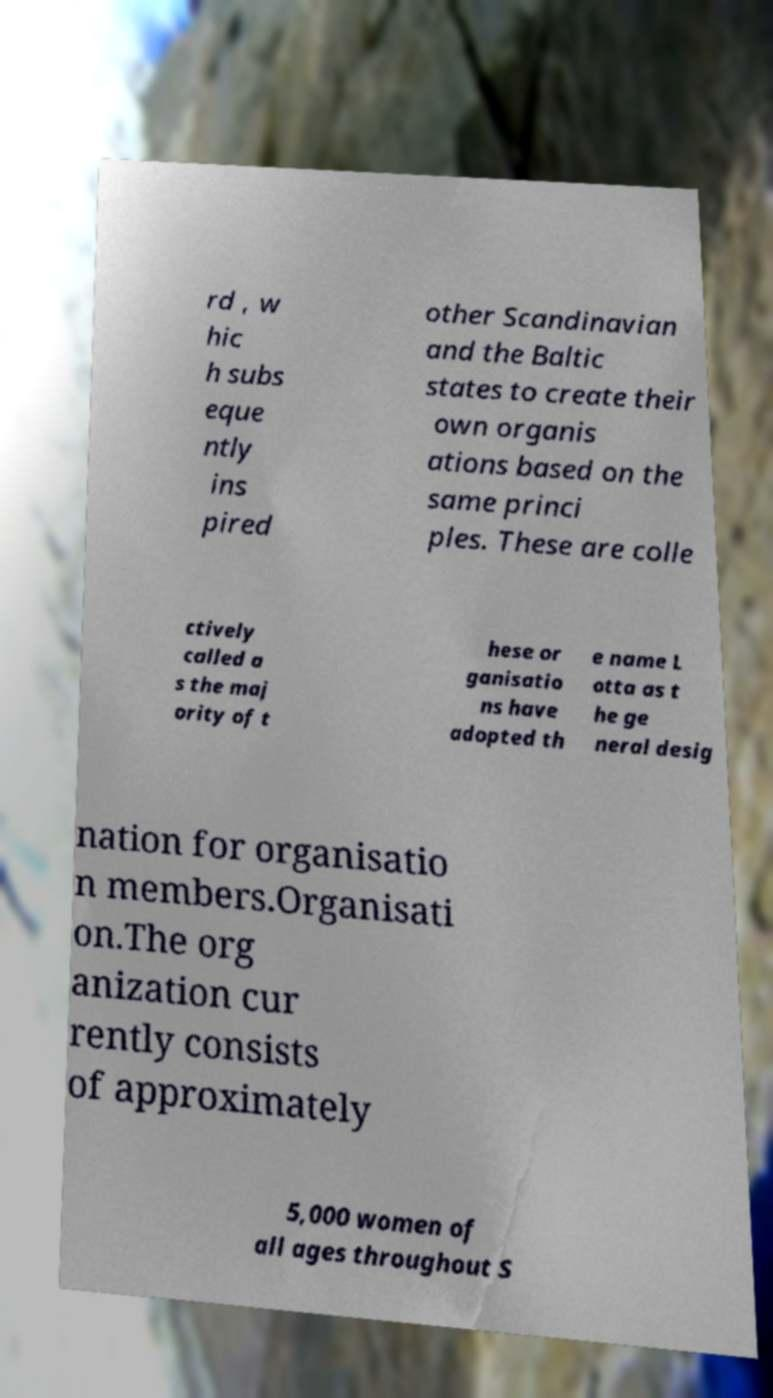Can you read and provide the text displayed in the image?This photo seems to have some interesting text. Can you extract and type it out for me? rd , w hic h subs eque ntly ins pired other Scandinavian and the Baltic states to create their own organis ations based on the same princi ples. These are colle ctively called a s the maj ority of t hese or ganisatio ns have adopted th e name L otta as t he ge neral desig nation for organisatio n members.Organisati on.The org anization cur rently consists of approximately 5,000 women of all ages throughout S 